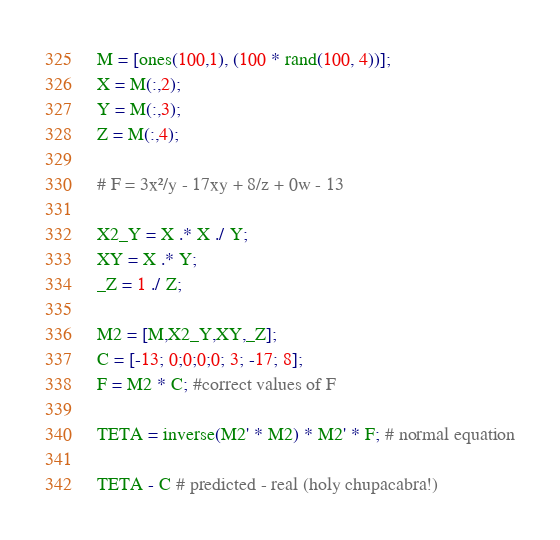<code> <loc_0><loc_0><loc_500><loc_500><_Octave_>M = [ones(100,1), (100 * rand(100, 4))];
X = M(:,2);
Y = M(:,3);
Z = M(:,4);

# F = 3x²/y - 17xy + 8/z + 0w - 13

X2_Y = X .* X ./ Y;
XY = X .* Y;
_Z = 1 ./ Z;

M2 = [M,X2_Y,XY,_Z];
C = [-13; 0;0;0;0; 3; -17; 8];
F = M2 * C; #correct values of F

TETA = inverse(M2' * M2) * M2' * F; # normal equation

TETA - C # predicted - real (holy chupacabra!)
</code> 